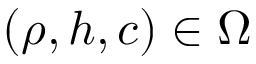<formula> <loc_0><loc_0><loc_500><loc_500>( \rho , h , c ) \in \Omega</formula> 